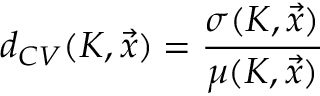<formula> <loc_0><loc_0><loc_500><loc_500>d _ { C V } ( K , \vec { x } ) = \frac { \sigma ( K , \vec { x } ) } { \mu ( K , \vec { x } ) }</formula> 